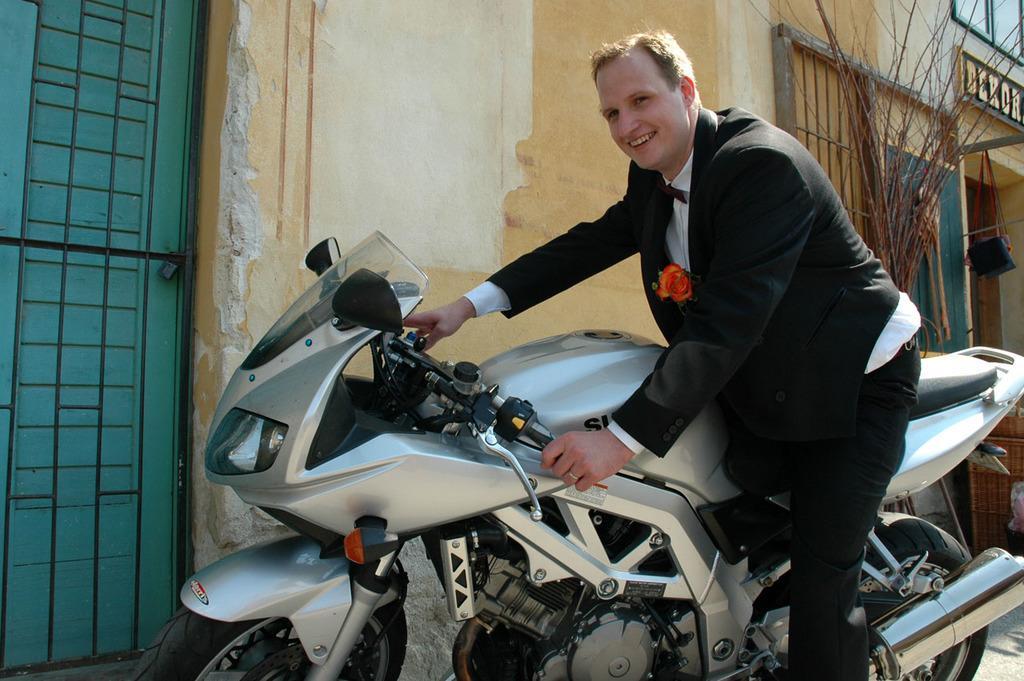Can you describe this image briefly? In the middle there is a bike on that bike there is a man he wear suit ,trouser and white shirt ,he is smiling. In the background there is a wall ,door,plant and text. 